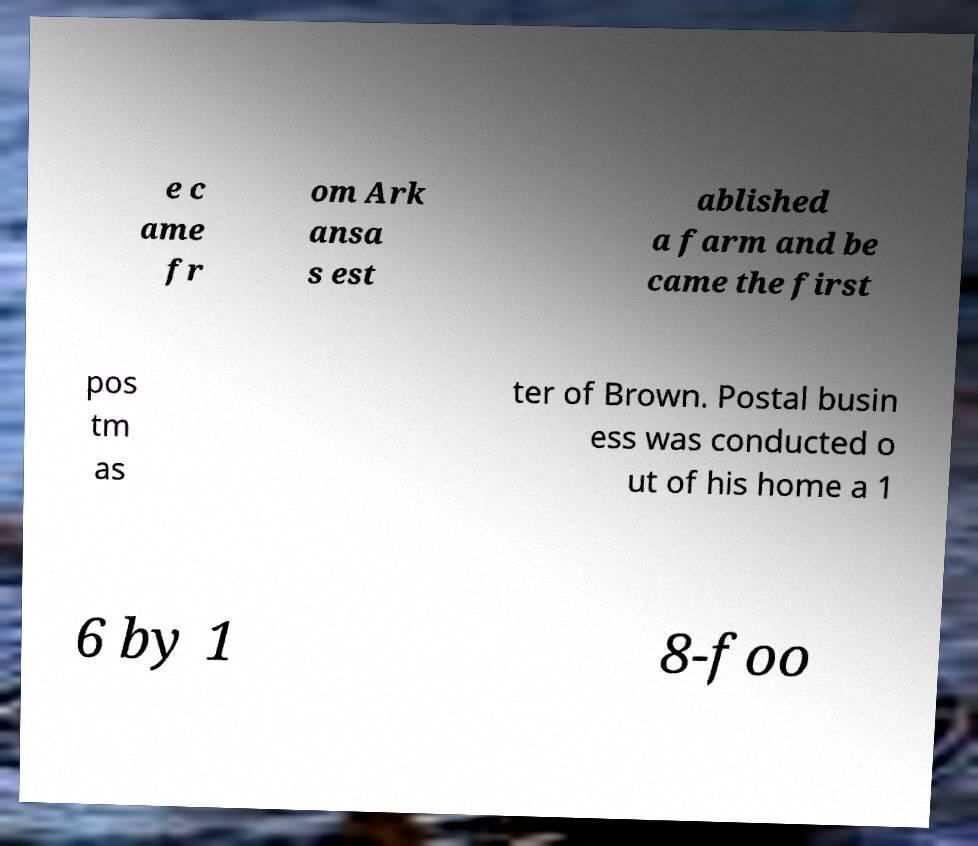Please read and relay the text visible in this image. What does it say? e c ame fr om Ark ansa s est ablished a farm and be came the first pos tm as ter of Brown. Postal busin ess was conducted o ut of his home a 1 6 by 1 8-foo 